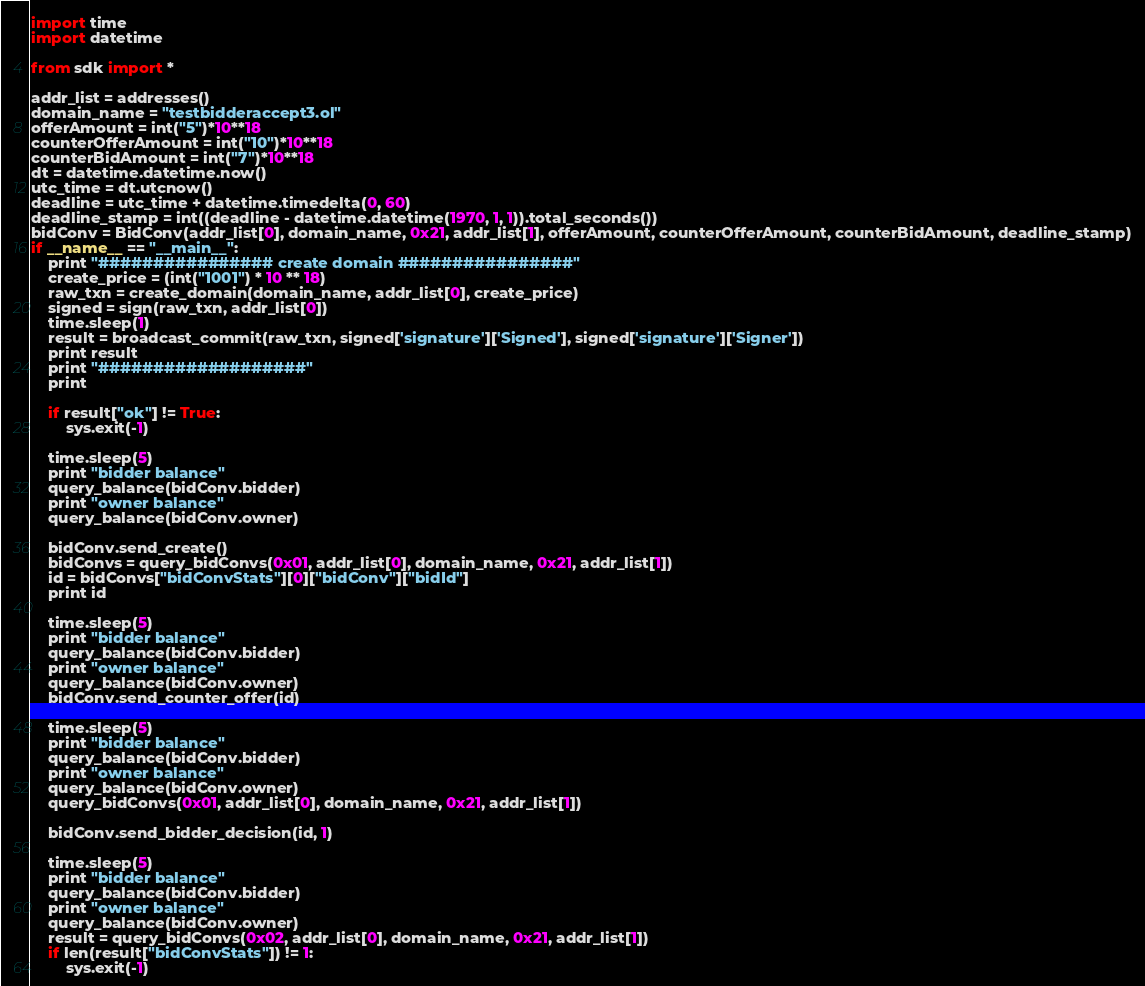<code> <loc_0><loc_0><loc_500><loc_500><_Python_>import time
import datetime

from sdk import *

addr_list = addresses()
domain_name = "testbidderaccept3.ol"
offerAmount = int("5")*10**18
counterOfferAmount = int("10")*10**18
counterBidAmount = int("7")*10**18
dt = datetime.datetime.now()
utc_time = dt.utcnow()
deadline = utc_time + datetime.timedelta(0, 60)
deadline_stamp = int((deadline - datetime.datetime(1970, 1, 1)).total_seconds())
bidConv = BidConv(addr_list[0], domain_name, 0x21, addr_list[1], offerAmount, counterOfferAmount, counterBidAmount, deadline_stamp)
if __name__ == "__main__":
    print "################ create domain ################"
    create_price = (int("1001") * 10 ** 18)
    raw_txn = create_domain(domain_name, addr_list[0], create_price)
    signed = sign(raw_txn, addr_list[0])
    time.sleep(1)
    result = broadcast_commit(raw_txn, signed['signature']['Signed'], signed['signature']['Signer'])
    print result
    print "###################"
    print

    if result["ok"] != True:
        sys.exit(-1)

    time.sleep(5)
    print "bidder balance"
    query_balance(bidConv.bidder)
    print "owner balance"
    query_balance(bidConv.owner)

    bidConv.send_create()
    bidConvs = query_bidConvs(0x01, addr_list[0], domain_name, 0x21, addr_list[1])
    id = bidConvs["bidConvStats"][0]["bidConv"]["bidId"]
    print id

    time.sleep(5)
    print "bidder balance"
    query_balance(bidConv.bidder)
    print "owner balance"
    query_balance(bidConv.owner)
    bidConv.send_counter_offer(id)

    time.sleep(5)
    print "bidder balance"
    query_balance(bidConv.bidder)
    print "owner balance"
    query_balance(bidConv.owner)
    query_bidConvs(0x01, addr_list[0], domain_name, 0x21, addr_list[1])

    bidConv.send_bidder_decision(id, 1)

    time.sleep(5)
    print "bidder balance"
    query_balance(bidConv.bidder)
    print "owner balance"
    query_balance(bidConv.owner)
    result = query_bidConvs(0x02, addr_list[0], domain_name, 0x21, addr_list[1])
    if len(result["bidConvStats"]) != 1:
        sys.exit(-1)



</code> 